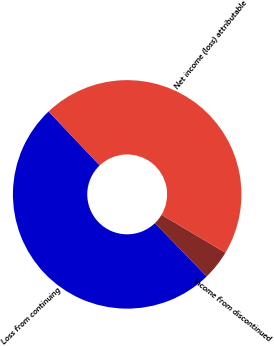Convert chart to OTSL. <chart><loc_0><loc_0><loc_500><loc_500><pie_chart><fcel>Loss from continuing<fcel>Income from discontinued<fcel>Net income (loss) attributable<nl><fcel>50.16%<fcel>4.23%<fcel>45.6%<nl></chart> 